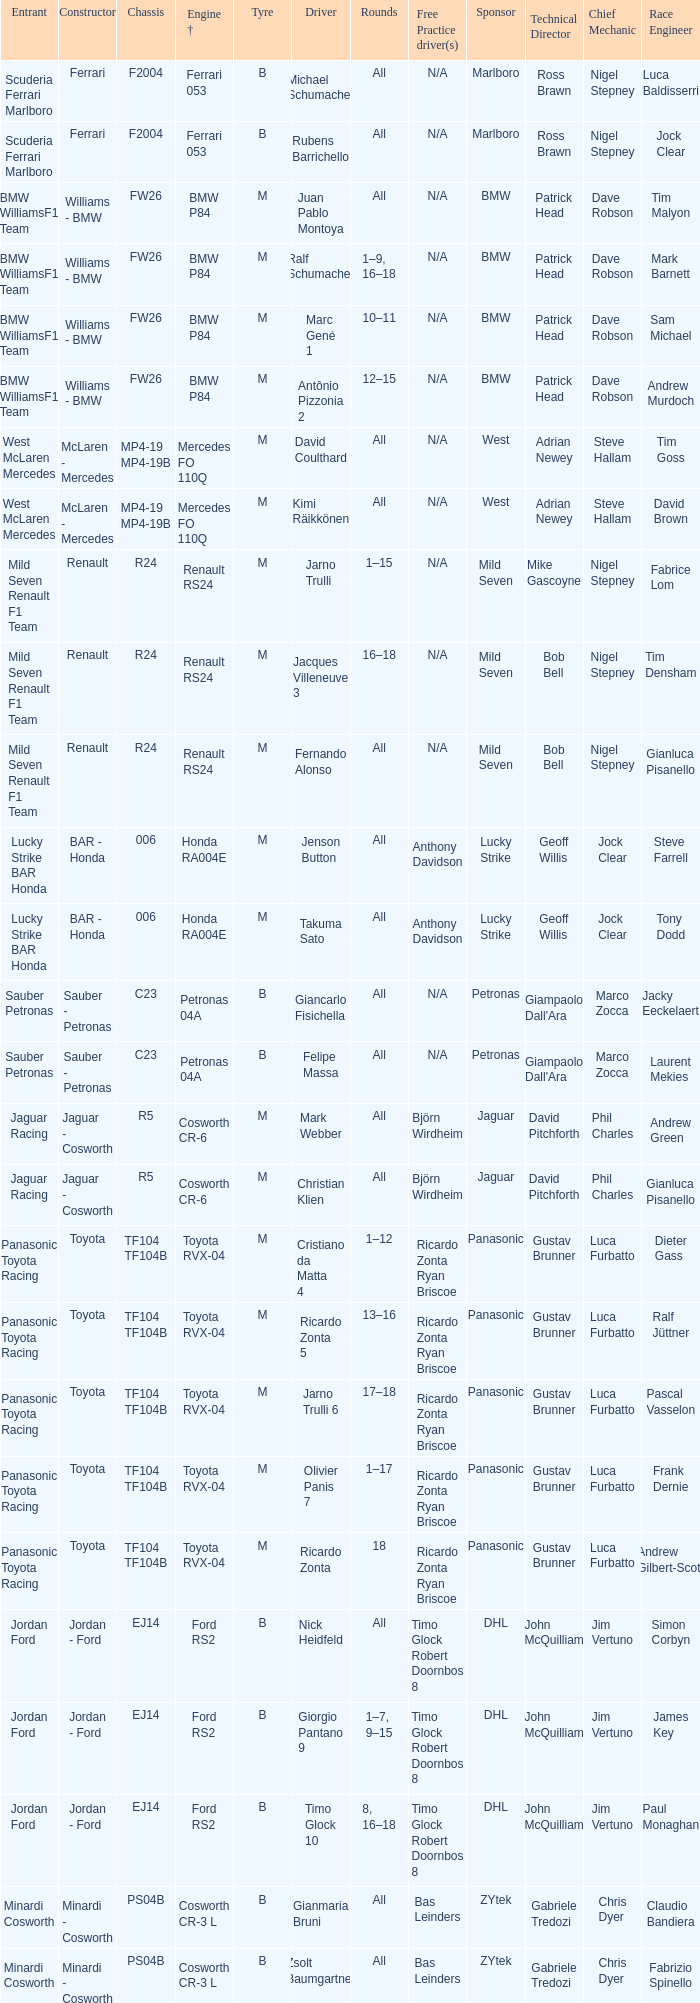What are the rounds for the B tyres and Ferrari 053 engine +? All, All. Can you parse all the data within this table? {'header': ['Entrant', 'Constructor', 'Chassis', 'Engine †', 'Tyre', 'Driver', 'Rounds', 'Free Practice driver(s)', 'Sponsor', 'Technical Director', 'Chief Mechanic', 'Race Engineer'], 'rows': [['Scuderia Ferrari Marlboro', 'Ferrari', 'F2004', 'Ferrari 053', 'B', 'Michael Schumacher', 'All', 'N/A', 'Marlboro', 'Ross Brawn', 'Nigel Stepney', 'Luca Baldisserri'], ['Scuderia Ferrari Marlboro', 'Ferrari', 'F2004', 'Ferrari 053', 'B', 'Rubens Barrichello', 'All', 'N/A', 'Marlboro', 'Ross Brawn', 'Nigel Stepney', 'Jock Clear'], ['BMW WilliamsF1 Team', 'Williams - BMW', 'FW26', 'BMW P84', 'M', 'Juan Pablo Montoya', 'All', 'N/A', 'BMW', 'Patrick Head', 'Dave Robson', 'Tim Malyon'], ['BMW WilliamsF1 Team', 'Williams - BMW', 'FW26', 'BMW P84', 'M', 'Ralf Schumacher', '1–9, 16–18', 'N/A', 'BMW', 'Patrick Head', 'Dave Robson', 'Mark Barnett'], ['BMW WilliamsF1 Team', 'Williams - BMW', 'FW26', 'BMW P84', 'M', 'Marc Gené 1', '10–11', 'N/A', 'BMW', 'Patrick Head', 'Dave Robson', 'Sam Michael'], ['BMW WilliamsF1 Team', 'Williams - BMW', 'FW26', 'BMW P84', 'M', 'Antônio Pizzonia 2', '12–15', 'N/A', 'BMW', 'Patrick Head', 'Dave Robson', 'Andrew Murdoch'], ['West McLaren Mercedes', 'McLaren - Mercedes', 'MP4-19 MP4-19B', 'Mercedes FO 110Q', 'M', 'David Coulthard', 'All', 'N/A', 'West', 'Adrian Newey', 'Steve Hallam', 'Tim Goss'], ['West McLaren Mercedes', 'McLaren - Mercedes', 'MP4-19 MP4-19B', 'Mercedes FO 110Q', 'M', 'Kimi Räikkönen', 'All', 'N/A', 'West', 'Adrian Newey', 'Steve Hallam', 'David Brown'], ['Mild Seven Renault F1 Team', 'Renault', 'R24', 'Renault RS24', 'M', 'Jarno Trulli', '1–15', 'N/A', 'Mild Seven', 'Mike Gascoyne', 'Nigel Stepney', 'Fabrice Lom'], ['Mild Seven Renault F1 Team', 'Renault', 'R24', 'Renault RS24', 'M', 'Jacques Villeneuve 3', '16–18', 'N/A', 'Mild Seven', 'Bob Bell', 'Nigel Stepney', 'Tim Densham'], ['Mild Seven Renault F1 Team', 'Renault', 'R24', 'Renault RS24', 'M', 'Fernando Alonso', 'All', 'N/A', 'Mild Seven', 'Bob Bell', 'Nigel Stepney', 'Gianluca Pisanello'], ['Lucky Strike BAR Honda', 'BAR - Honda', '006', 'Honda RA004E', 'M', 'Jenson Button', 'All', 'Anthony Davidson', 'Lucky Strike', 'Geoff Willis', 'Jock Clear', 'Steve Farrell'], ['Lucky Strike BAR Honda', 'BAR - Honda', '006', 'Honda RA004E', 'M', 'Takuma Sato', 'All', 'Anthony Davidson', 'Lucky Strike', 'Geoff Willis', 'Jock Clear', 'Tony Dodd'], ['Sauber Petronas', 'Sauber - Petronas', 'C23', 'Petronas 04A', 'B', 'Giancarlo Fisichella', 'All', 'N/A', 'Petronas', "Giampaolo Dall'Ara", 'Marco Zocca', 'Jacky Eeckelaert'], ['Sauber Petronas', 'Sauber - Petronas', 'C23', 'Petronas 04A', 'B', 'Felipe Massa', 'All', 'N/A', 'Petronas', "Giampaolo Dall'Ara", 'Marco Zocca', 'Laurent Mekies'], ['Jaguar Racing', 'Jaguar - Cosworth', 'R5', 'Cosworth CR-6', 'M', 'Mark Webber', 'All', 'Björn Wirdheim', 'Jaguar', 'David Pitchforth', 'Phil Charles', 'Andrew Green'], ['Jaguar Racing', 'Jaguar - Cosworth', 'R5', 'Cosworth CR-6', 'M', 'Christian Klien', 'All', 'Björn Wirdheim', 'Jaguar', 'David Pitchforth', 'Phil Charles', 'Gianluca Pisanello'], ['Panasonic Toyota Racing', 'Toyota', 'TF104 TF104B', 'Toyota RVX-04', 'M', 'Cristiano da Matta 4', '1–12', 'Ricardo Zonta Ryan Briscoe', 'Panasonic', 'Gustav Brunner', 'Luca Furbatto', 'Dieter Gass'], ['Panasonic Toyota Racing', 'Toyota', 'TF104 TF104B', 'Toyota RVX-04', 'M', 'Ricardo Zonta 5', '13–16', 'Ricardo Zonta Ryan Briscoe', 'Panasonic', 'Gustav Brunner', 'Luca Furbatto', 'Ralf Jüttner'], ['Panasonic Toyota Racing', 'Toyota', 'TF104 TF104B', 'Toyota RVX-04', 'M', 'Jarno Trulli 6', '17–18', 'Ricardo Zonta Ryan Briscoe', 'Panasonic', 'Gustav Brunner', 'Luca Furbatto', 'Pascal Vasselon'], ['Panasonic Toyota Racing', 'Toyota', 'TF104 TF104B', 'Toyota RVX-04', 'M', 'Olivier Panis 7', '1–17', 'Ricardo Zonta Ryan Briscoe', 'Panasonic', 'Gustav Brunner', 'Luca Furbatto', 'Frank Dernie'], ['Panasonic Toyota Racing', 'Toyota', 'TF104 TF104B', 'Toyota RVX-04', 'M', 'Ricardo Zonta', '18', 'Ricardo Zonta Ryan Briscoe', 'Panasonic', 'Gustav Brunner', 'Luca Furbatto', 'Andrew Gilbert-Scott'], ['Jordan Ford', 'Jordan - Ford', 'EJ14', 'Ford RS2', 'B', 'Nick Heidfeld', 'All', 'Timo Glock Robert Doornbos 8', 'DHL', 'John McQuilliam', 'Jim Vertuno', 'Simon Corbyn'], ['Jordan Ford', 'Jordan - Ford', 'EJ14', 'Ford RS2', 'B', 'Giorgio Pantano 9', '1–7, 9–15', 'Timo Glock Robert Doornbos 8', 'DHL', 'John McQuilliam', 'Jim Vertuno', 'James Key'], ['Jordan Ford', 'Jordan - Ford', 'EJ14', 'Ford RS2', 'B', 'Timo Glock 10', '8, 16–18', 'Timo Glock Robert Doornbos 8', 'DHL', 'John McQuilliam', 'Jim Vertuno', 'Paul Monaghan'], ['Minardi Cosworth', 'Minardi - Cosworth', 'PS04B', 'Cosworth CR-3 L', 'B', 'Gianmaria Bruni', 'All', 'Bas Leinders', 'ZYtek', 'Gabriele Tredozi', 'Chris Dyer', 'Claudio Bandiera'], ['Minardi Cosworth', 'Minardi - Cosworth', 'PS04B', 'Cosworth CR-3 L', 'B', 'Zsolt Baumgartner', 'All', 'Bas Leinders', 'ZYtek', 'Gabriele Tredozi', 'Chris Dyer', 'Fabrizio Spinello']]} 